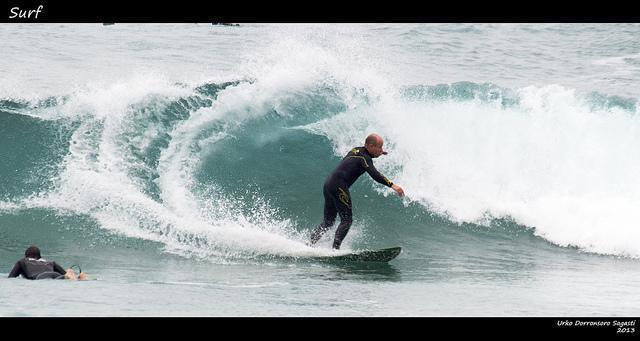What type of hairline does the standing man have?
Answer the question by selecting the correct answer among the 4 following choices.
Options: Triangle, receding, straight, widow's peak. Receding. 